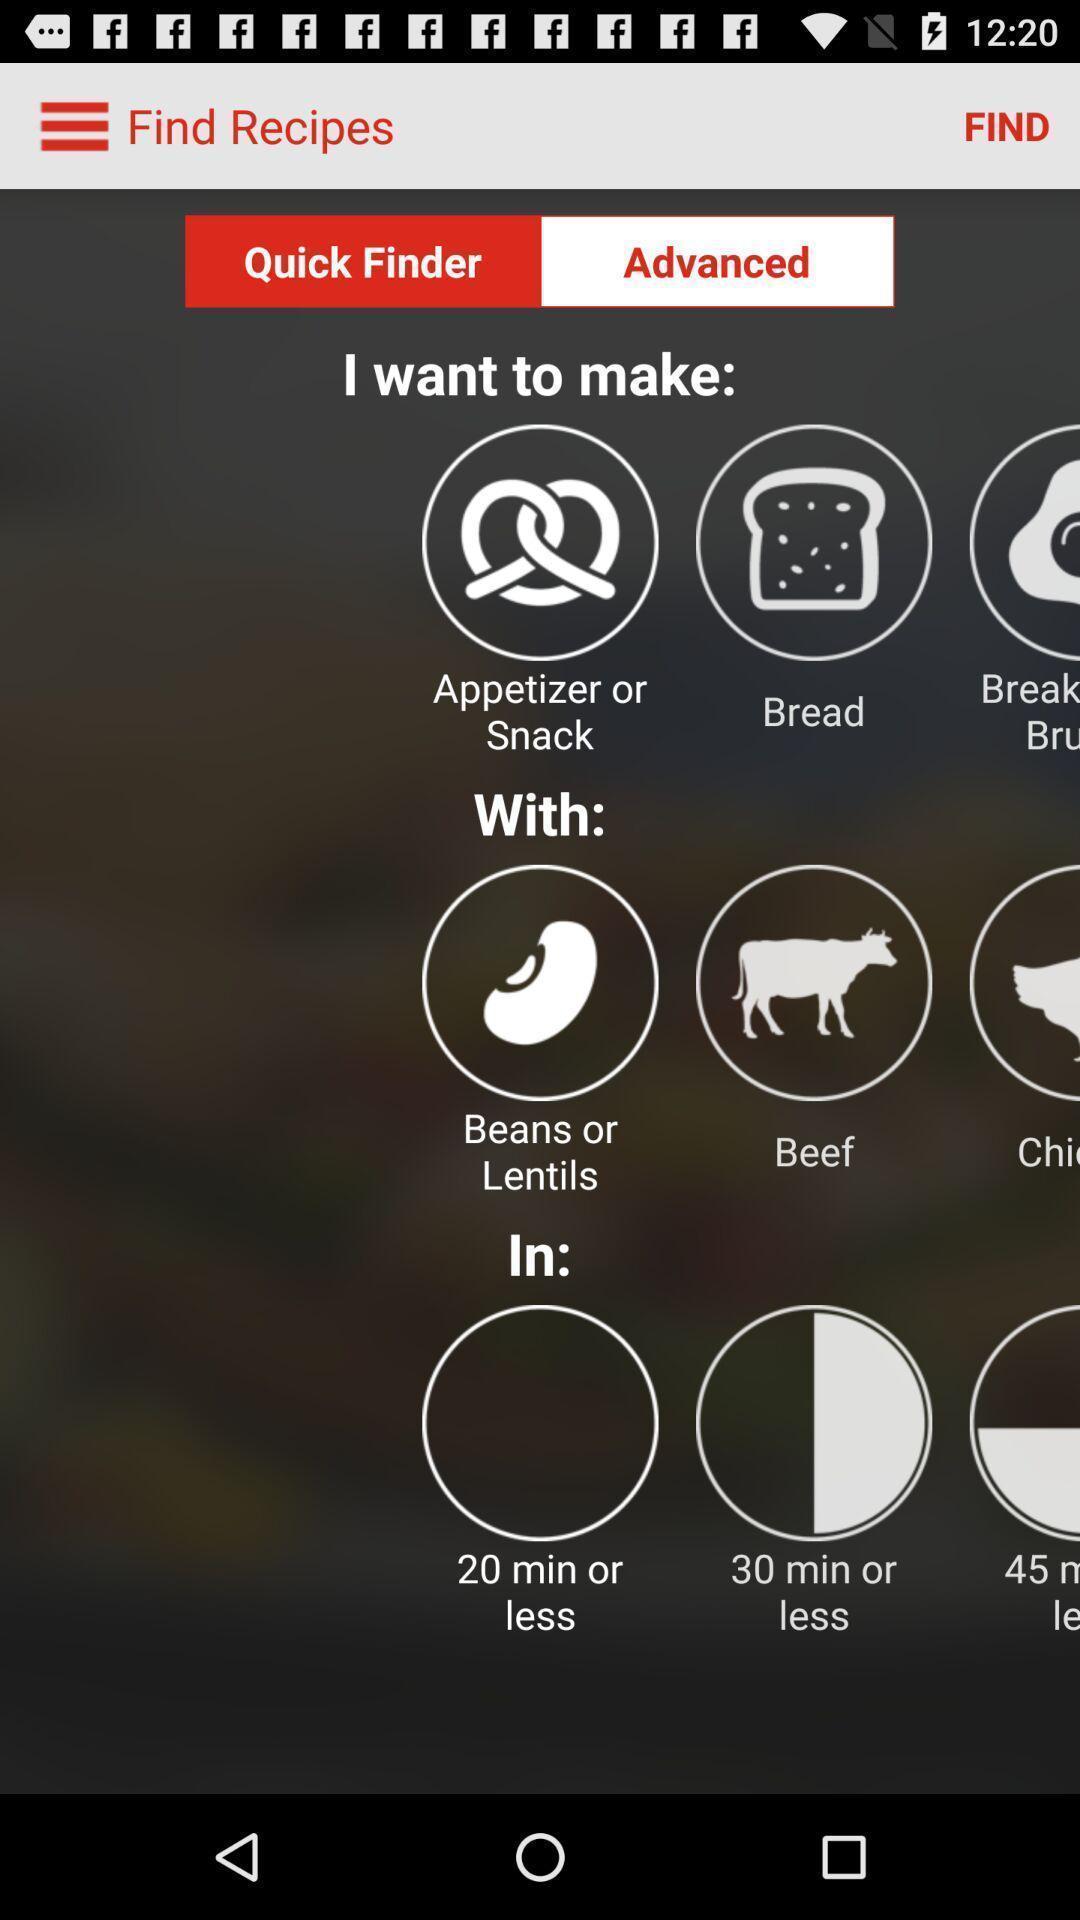Describe the content in this image. Screen showing find recipes with items and time. 